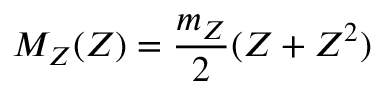Convert formula to latex. <formula><loc_0><loc_0><loc_500><loc_500>M _ { Z } ( Z ) = \frac { m _ { Z } } { 2 } ( Z + Z ^ { 2 } )</formula> 